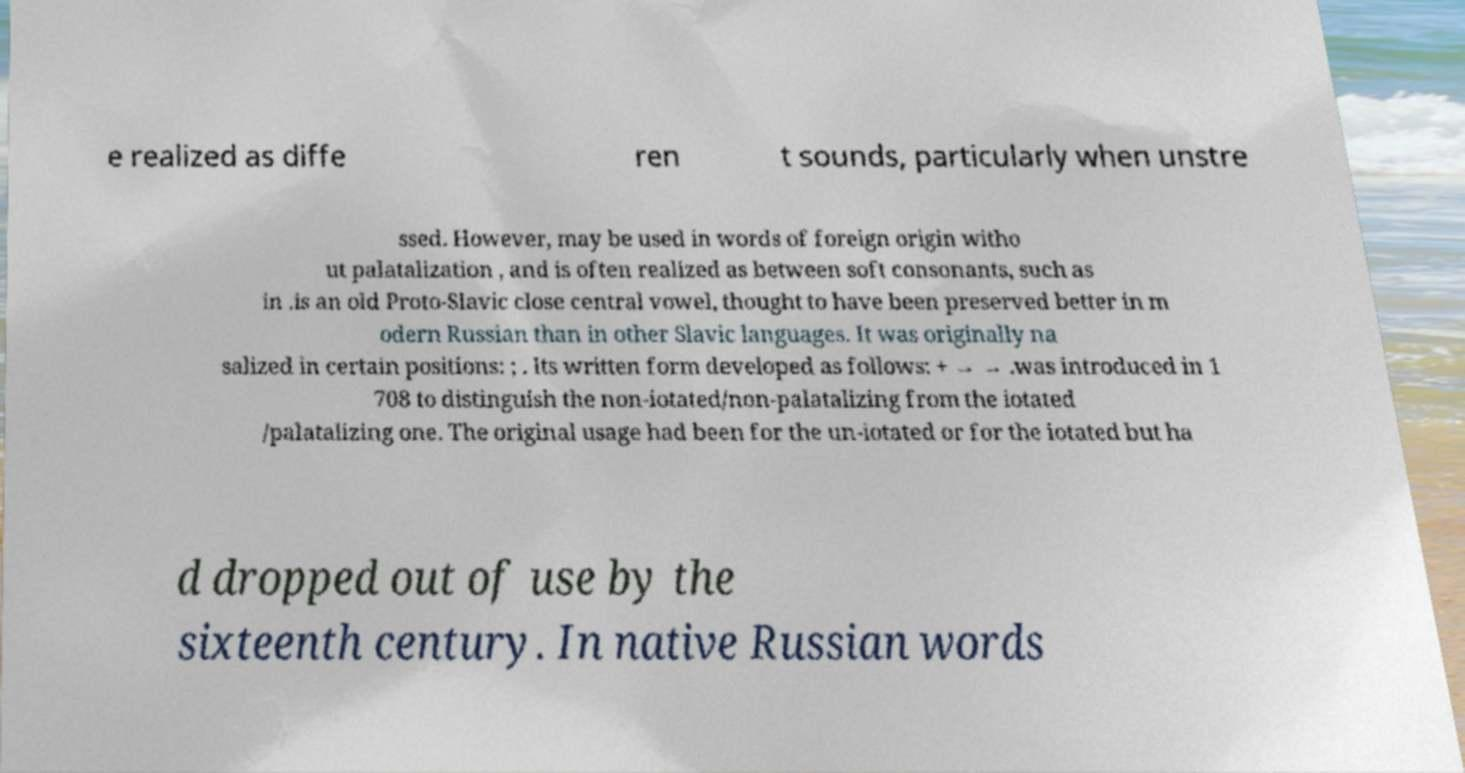What messages or text are displayed in this image? I need them in a readable, typed format. e realized as diffe ren t sounds, particularly when unstre ssed. However, may be used in words of foreign origin witho ut palatalization , and is often realized as between soft consonants, such as in .is an old Proto-Slavic close central vowel, thought to have been preserved better in m odern Russian than in other Slavic languages. It was originally na salized in certain positions: ; . Its written form developed as follows: + → → .was introduced in 1 708 to distinguish the non-iotated/non-palatalizing from the iotated /palatalizing one. The original usage had been for the un-iotated or for the iotated but ha d dropped out of use by the sixteenth century. In native Russian words 